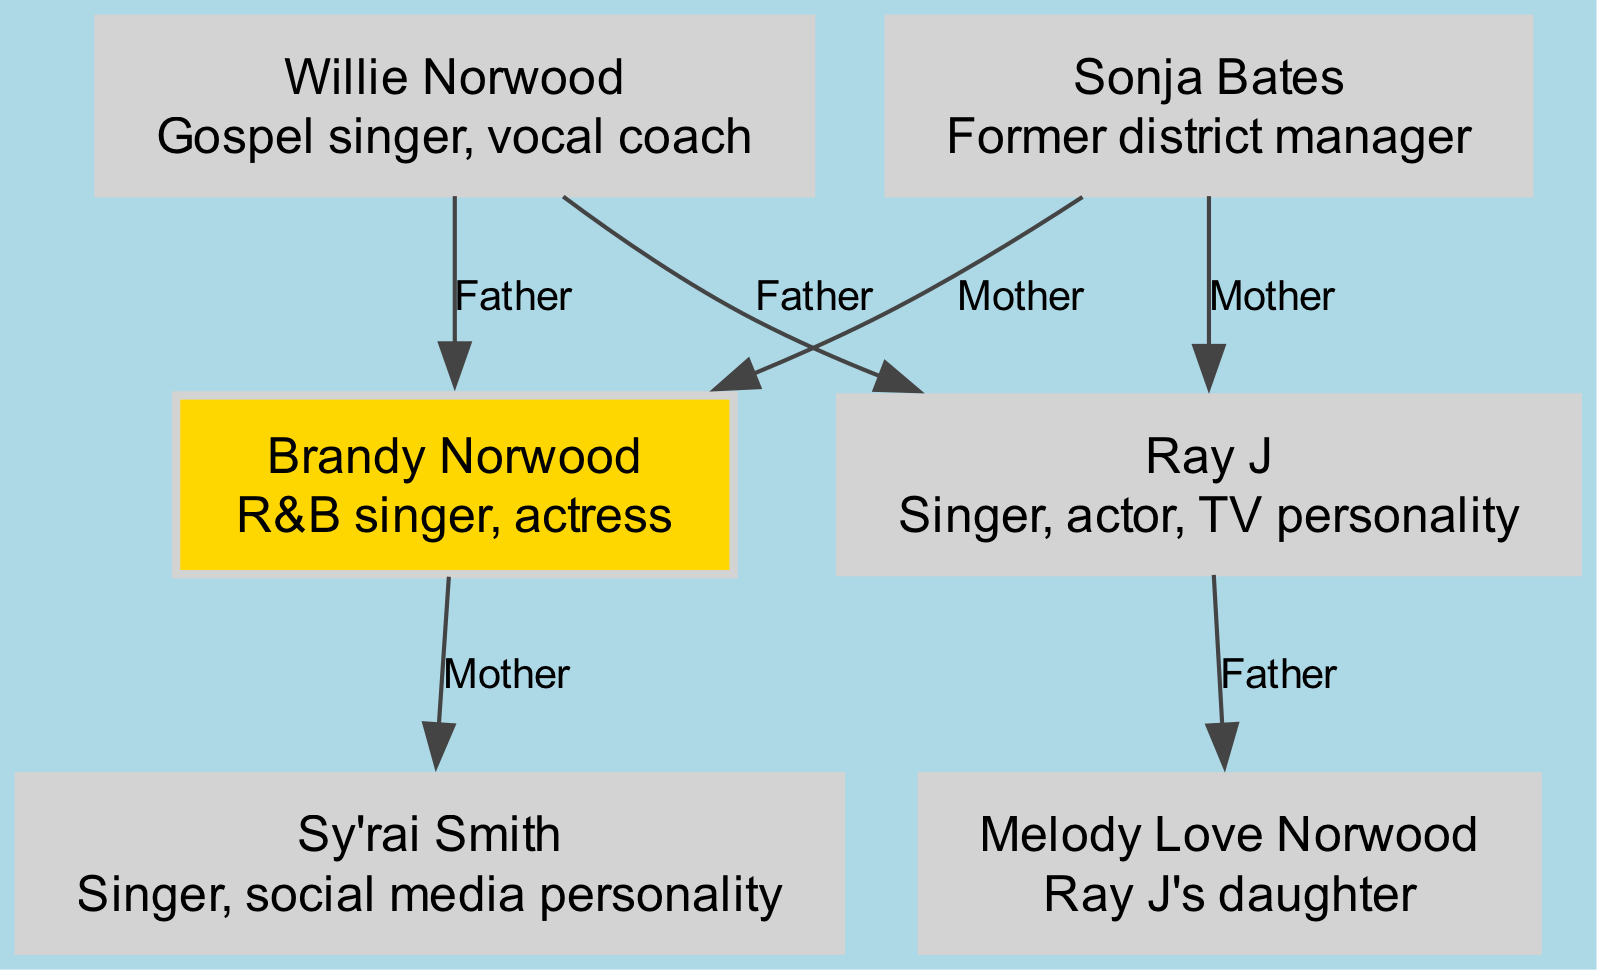What is the role of Brandy Norwood? The diagram indicates that Brandy Norwood's role is defined as "R&B singer, actress." This information is directly stated in her node within the family tree.
Answer: R&B singer, actress How many children does Willie Norwood have? The diagram shows that Willie Norwood is connected to both Brandy Norwood and Ray J as their father. This indicates that he has two children.
Answer: 2 Who is the daughter of Ray J? The family tree specifies that Ray J is the father of Melody Love Norwood, as indicated by the relationship line connecting Ray J to Melody.
Answer: Melody Love Norwood What relationship does Sy'rai Smith have with Brandy Norwood? The diagram illustrates that Brandy Norwood is the mother of Sy'rai Smith, represented by the direct connection labeled "Mother."
Answer: Mother Which two roles are listed for the node labeled Willie Norwood? Referring to the node for Willie Norwood in the diagram, his roles are "Gospel singer" and "vocal coach," which are both mentioned in the node's description.
Answer: Gospel singer, vocal coach How many total nodes are present in the family tree? The total number of unique individuals (nodes) listed in the diagram is counted. According to the data provided, there are six nodes: Willie Norwood, Sonja Bates, Brandy Norwood, Ray J, Sy'rai Smith, and Melody Love Norwood.
Answer: 6 What is the relationship between Ray J and Melody Love Norwood? The diagram clearly shows a directed edge from Ray J to Melody Love Norwood labeled as "Father," indicating that Ray J is her father.
Answer: Father Who are the parents of Brandy Norwood? The diagram displays two edges leading to Brandy Norwood, one from Willie Norwood (father) and another from Sonja Bates (mother), indicating both parents are listed.
Answer: Willie Norwood and Sonja Bates Which node has the role of "singer, social media personality"? Upon examining the nodes, it is evident that the node for Sy'rai Smith describes her role as "Singer, social media personality," thus identifying her with these roles.
Answer: Sy'rai Smith 